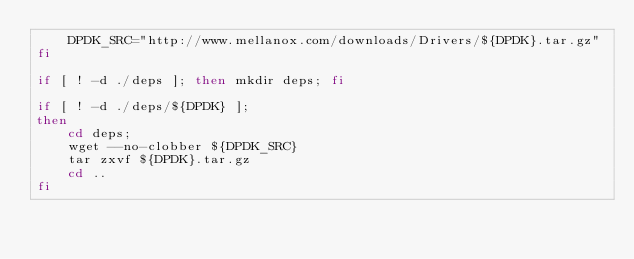Convert code to text. <code><loc_0><loc_0><loc_500><loc_500><_Bash_>    DPDK_SRC="http://www.mellanox.com/downloads/Drivers/${DPDK}.tar.gz"
fi

if [ ! -d ./deps ]; then mkdir deps; fi

if [ ! -d ./deps/${DPDK} ];
then
    cd deps;
    wget --no-clobber ${DPDK_SRC}
    tar zxvf ${DPDK}.tar.gz
    cd ..
fi</code> 